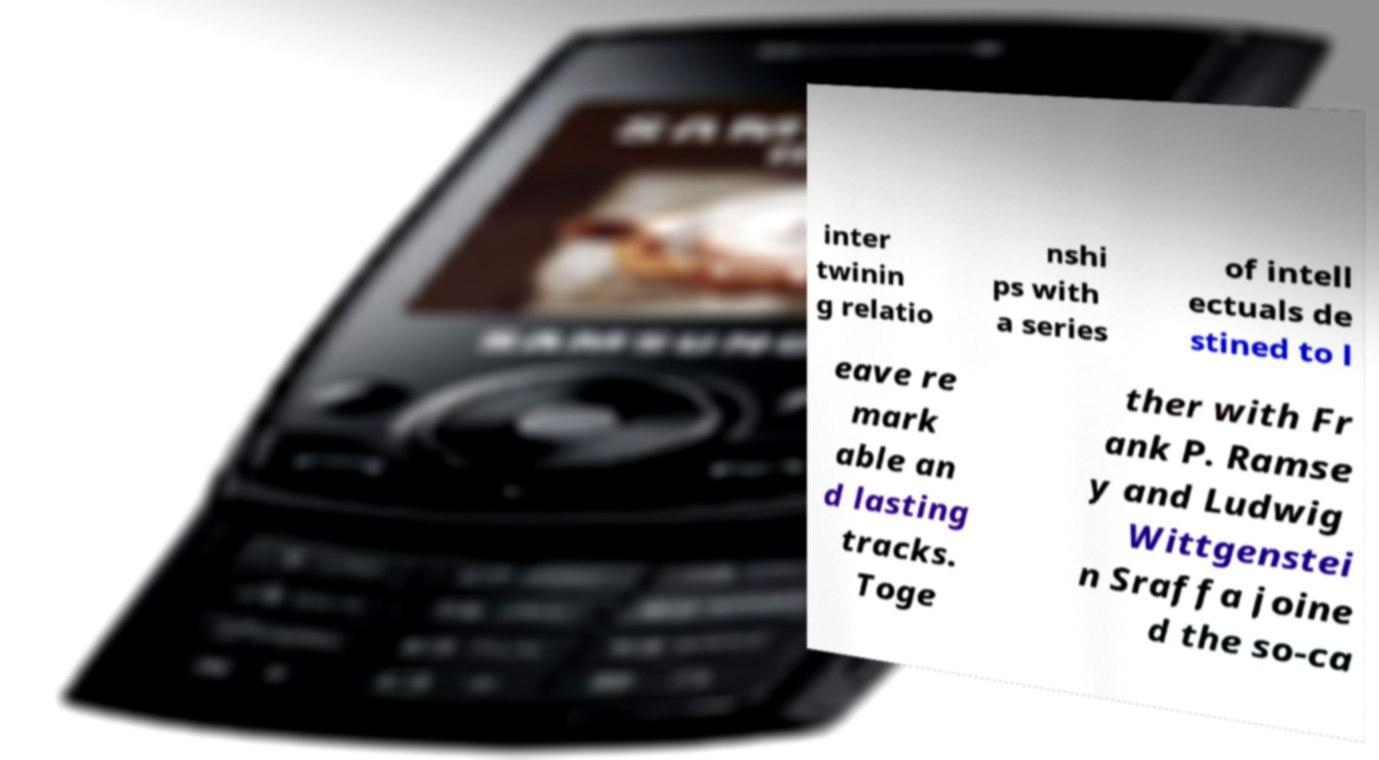Please identify and transcribe the text found in this image. inter twinin g relatio nshi ps with a series of intell ectuals de stined to l eave re mark able an d lasting tracks. Toge ther with Fr ank P. Ramse y and Ludwig Wittgenstei n Sraffa joine d the so-ca 